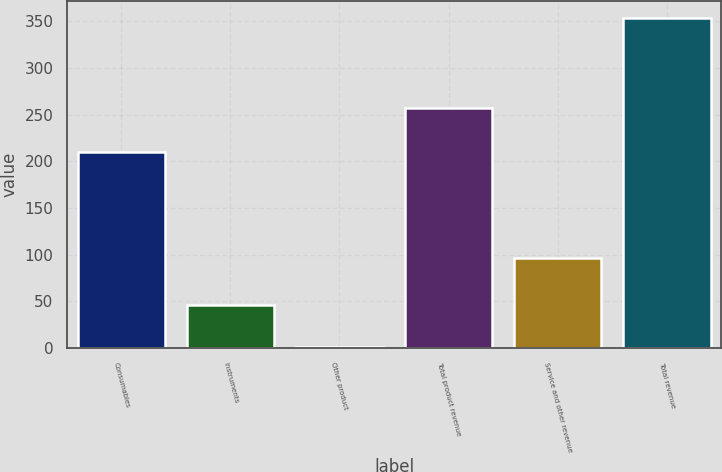<chart> <loc_0><loc_0><loc_500><loc_500><bar_chart><fcel>Consumables<fcel>Instruments<fcel>Other product<fcel>Total product revenue<fcel>Service and other revenue<fcel>Total revenue<nl><fcel>210<fcel>46<fcel>1<fcel>257<fcel>97<fcel>354<nl></chart> 